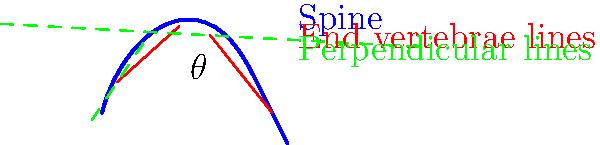In the X-ray image of a patient with scoliosis, the Cobb angle ($\theta$) is determined using the method illustrated. If the angle between the red lines is measured to be $38^\circ$, what is the actual Cobb angle? Express your answer in degrees and round to the nearest whole number. Let's approach this step-by-step, applying our knowledge of spinal radiography and geometry:

1) The Cobb angle is defined as the angle between perpendicular lines drawn to the endplates of the most tilted vertebrae at the top and bottom of the spinal curve.

2) In the diagram, the red lines represent the endplates of the most tilted vertebrae.

3) The green dashed lines are perpendicular to these endplates.

4) The angle between the red lines ($38^\circ$) is not the Cobb angle itself, but it's related.

5) Recall from geometry that when two lines intersect, alternate angles are equal. This means that the Cobb angle ($\theta$) is supplementary to the angle between the red lines.

6) In mathematics, supplementary angles add up to $180^\circ$.

7) Therefore, we can calculate the Cobb angle using the formula:

   $\theta = 180^\circ - 38^\circ = 142^\circ$

8) Rounding to the nearest whole number: $142^\circ$

This method of calculation ensures we're measuring the true angle of spinal curvature, which is critical for accurate diagnosis and treatment planning in scoliosis cases.
Answer: $142^\circ$ 